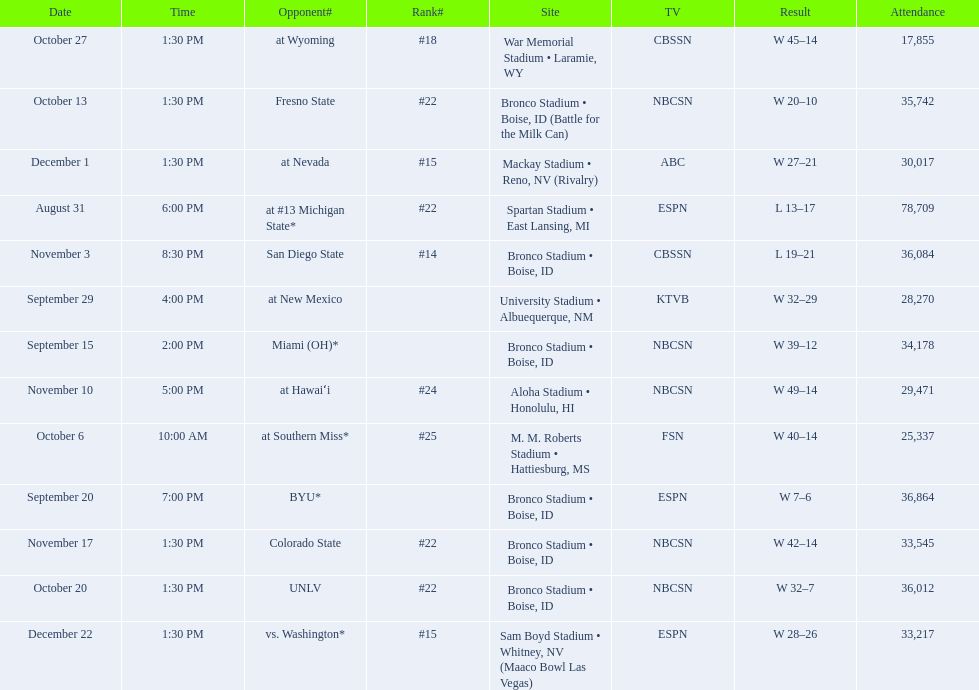What are the opponent teams of the 2012 boise state broncos football team? At #13 michigan state*, miami (oh)*, byu*, at new mexico, at southern miss*, fresno state, unlv, at wyoming, san diego state, at hawaiʻi, colorado state, at nevada, vs. washington*. How has the highest rank of these opponents? San Diego State. 